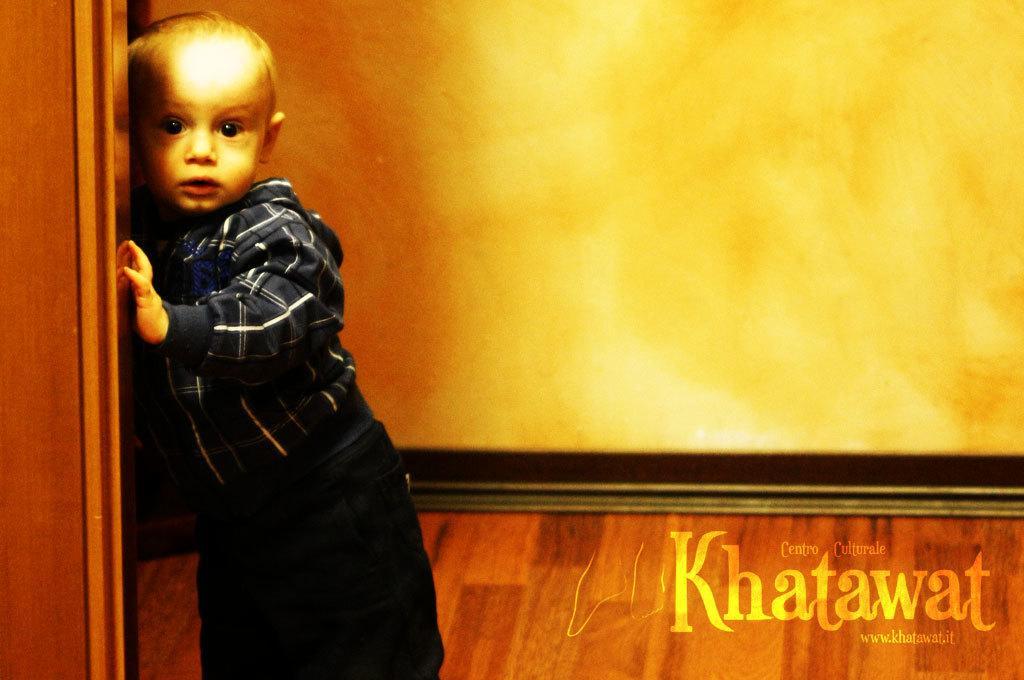Can you describe this image briefly? On the left there is a kid holding a wooden object. On the right there is text. In the center of the picture it is well. 